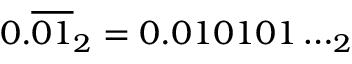Convert formula to latex. <formula><loc_0><loc_0><loc_500><loc_500>0 . { \overline { 0 1 } } _ { 2 } = 0 . 0 1 0 1 0 1 \dots _ { 2 }</formula> 